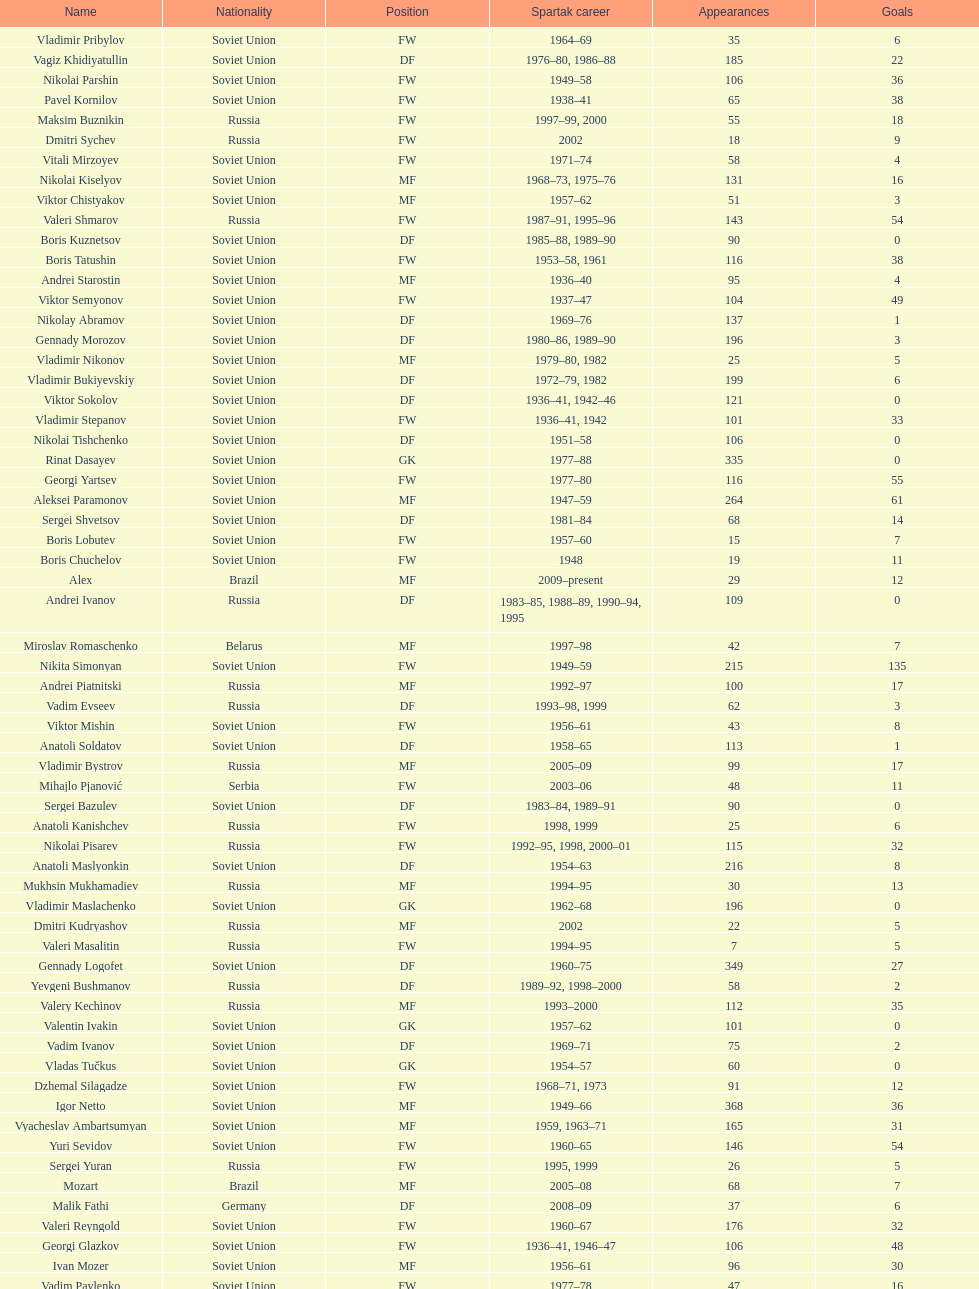How many players had at least 20 league goals scored? 56. Can you give me this table as a dict? {'header': ['Name', 'Nationality', 'Position', 'Spartak career', 'Appearances', 'Goals'], 'rows': [['Vladimir Pribylov', 'Soviet Union', 'FW', '1964–69', '35', '6'], ['Vagiz Khidiyatullin', 'Soviet Union', 'DF', '1976–80, 1986–88', '185', '22'], ['Nikolai Parshin', 'Soviet Union', 'FW', '1949–58', '106', '36'], ['Pavel Kornilov', 'Soviet Union', 'FW', '1938–41', '65', '38'], ['Maksim Buznikin', 'Russia', 'FW', '1997–99, 2000', '55', '18'], ['Dmitri Sychev', 'Russia', 'FW', '2002', '18', '9'], ['Vitali Mirzoyev', 'Soviet Union', 'FW', '1971–74', '58', '4'], ['Nikolai Kiselyov', 'Soviet Union', 'MF', '1968–73, 1975–76', '131', '16'], ['Viktor Chistyakov', 'Soviet Union', 'MF', '1957–62', '51', '3'], ['Valeri Shmarov', 'Russia', 'FW', '1987–91, 1995–96', '143', '54'], ['Boris Kuznetsov', 'Soviet Union', 'DF', '1985–88, 1989–90', '90', '0'], ['Boris Tatushin', 'Soviet Union', 'FW', '1953–58, 1961', '116', '38'], ['Andrei Starostin', 'Soviet Union', 'MF', '1936–40', '95', '4'], ['Viktor Semyonov', 'Soviet Union', 'FW', '1937–47', '104', '49'], ['Nikolay Abramov', 'Soviet Union', 'DF', '1969–76', '137', '1'], ['Gennady Morozov', 'Soviet Union', 'DF', '1980–86, 1989–90', '196', '3'], ['Vladimir Nikonov', 'Soviet Union', 'MF', '1979–80, 1982', '25', '5'], ['Vladimir Bukiyevskiy', 'Soviet Union', 'DF', '1972–79, 1982', '199', '6'], ['Viktor Sokolov', 'Soviet Union', 'DF', '1936–41, 1942–46', '121', '0'], ['Vladimir Stepanov', 'Soviet Union', 'FW', '1936–41, 1942', '101', '33'], ['Nikolai Tishchenko', 'Soviet Union', 'DF', '1951–58', '106', '0'], ['Rinat Dasayev', 'Soviet Union', 'GK', '1977–88', '335', '0'], ['Georgi Yartsev', 'Soviet Union', 'FW', '1977–80', '116', '55'], ['Aleksei Paramonov', 'Soviet Union', 'MF', '1947–59', '264', '61'], ['Sergei Shvetsov', 'Soviet Union', 'DF', '1981–84', '68', '14'], ['Boris Lobutev', 'Soviet Union', 'FW', '1957–60', '15', '7'], ['Boris Chuchelov', 'Soviet Union', 'FW', '1948', '19', '11'], ['Alex', 'Brazil', 'MF', '2009–present', '29', '12'], ['Andrei Ivanov', 'Russia', 'DF', '1983–85, 1988–89, 1990–94, 1995', '109', '0'], ['Miroslav Romaschenko', 'Belarus', 'MF', '1997–98', '42', '7'], ['Nikita Simonyan', 'Soviet Union', 'FW', '1949–59', '215', '135'], ['Andrei Piatnitski', 'Russia', 'MF', '1992–97', '100', '17'], ['Vadim Evseev', 'Russia', 'DF', '1993–98, 1999', '62', '3'], ['Viktor Mishin', 'Soviet Union', 'FW', '1956–61', '43', '8'], ['Anatoli Soldatov', 'Soviet Union', 'DF', '1958–65', '113', '1'], ['Vladimir Bystrov', 'Russia', 'MF', '2005–09', '99', '17'], ['Mihajlo Pjanović', 'Serbia', 'FW', '2003–06', '48', '11'], ['Sergei Bazulev', 'Soviet Union', 'DF', '1983–84, 1989–91', '90', '0'], ['Anatoli Kanishchev', 'Russia', 'FW', '1998, 1999', '25', '6'], ['Nikolai Pisarev', 'Russia', 'FW', '1992–95, 1998, 2000–01', '115', '32'], ['Anatoli Maslyonkin', 'Soviet Union', 'DF', '1954–63', '216', '8'], ['Mukhsin Mukhamadiev', 'Russia', 'MF', '1994–95', '30', '13'], ['Vladimir Maslachenko', 'Soviet Union', 'GK', '1962–68', '196', '0'], ['Dmitri Kudryashov', 'Russia', 'MF', '2002', '22', '5'], ['Valeri Masalitin', 'Russia', 'FW', '1994–95', '7', '5'], ['Gennady Logofet', 'Soviet Union', 'DF', '1960–75', '349', '27'], ['Yevgeni Bushmanov', 'Russia', 'DF', '1989–92, 1998–2000', '58', '2'], ['Valery Kechinov', 'Russia', 'MF', '1993–2000', '112', '35'], ['Valentin Ivakin', 'Soviet Union', 'GK', '1957–62', '101', '0'], ['Vadim Ivanov', 'Soviet Union', 'DF', '1969–71', '75', '2'], ['Vladas Tučkus', 'Soviet Union', 'GK', '1954–57', '60', '0'], ['Dzhemal Silagadze', 'Soviet Union', 'FW', '1968–71, 1973', '91', '12'], ['Igor Netto', 'Soviet Union', 'MF', '1949–66', '368', '36'], ['Vyacheslav Ambartsumyan', 'Soviet Union', 'MF', '1959, 1963–71', '165', '31'], ['Yuri Sevidov', 'Soviet Union', 'FW', '1960–65', '146', '54'], ['Sergei Yuran', 'Russia', 'FW', '1995, 1999', '26', '5'], ['Mozart', 'Brazil', 'MF', '2005–08', '68', '7'], ['Malik Fathi', 'Germany', 'DF', '2008–09', '37', '6'], ['Valeri Reyngold', 'Soviet Union', 'FW', '1960–67', '176', '32'], ['Georgi Glazkov', 'Soviet Union', 'FW', '1936–41, 1946–47', '106', '48'], ['Ivan Mozer', 'Soviet Union', 'MF', '1956–61', '96', '30'], ['Vadim Pavlenko', 'Soviet Union', 'FW', '1977–78', '47', '16'], ['Mikhail Bulgakov', 'Soviet Union', 'MF', '1970–79', '205', '39'], ['Aleksei Sokolov', 'Soviet Union', 'FW', '1938–41, 1942, 1944–47', '114', '49'], ['Yuri Kovtun', 'Russia', 'DF', '1999–2005', '122', '7'], ['Vladimir Petrov', 'Soviet Union', 'DF', '1959–71', '174', '5'], ['Anatoli Ilyin', 'Soviet Union', 'FW', '1949–62', '228', '84'], ['Anatoli Seglin', 'Soviet Union', 'DF', '1945–52', '83', '0'], ['Valeri Dikaryov', 'Soviet Union', 'DF', '1961–67', '192', '1'], ['Andrei Rudakov', 'Soviet Union', 'FW', '1985–87', '49', '17'], ['Aleksandr Kokorev', 'Soviet Union', 'MF', '1972–80', '90', '4'], ['Artyom Bezrodny', 'Russia', 'MF', '1995–97, 1998–2003', '55', '10'], ['Andrejs Štolcers', 'Latvia', 'MF', '2000', '11', '5'], ['Sergey Rodionov', 'Russia', 'FW', '1979–90, 1993–95', '303', '124'], ['Andrei Protasov', 'Soviet Union', 'FW', '1939–41', '32', '10'], ['Konstantin Malinin', 'Soviet Union', 'DF', '1939–50', '140', '7'], ['Aleksandr Bubnov', 'Soviet Union', 'DF', '1983–89', '169', '3'], ['Sergei Rozhkov', 'Soviet Union', 'MF', '1961–65, 1967–69, 1974', '143', '8'], ['Valeri Gladilin', 'Soviet Union', 'MF', '1974–78, 1983–84', '169', '28'], ['Dmitri Popov', 'Russia', 'DF', '1989–93', '78', '7'], ['Evgeny Lovchev', 'Soviet Union', 'MF', '1969–78', '249', '30'], ['Viktor Konovalov', 'Soviet Union', 'MF', '1960–61', '24', '5'], ['Viktor Samokhin', 'Soviet Union', 'MF', '1974–81', '188', '3'], ['Dmitri Radchenko', 'Russia', 'FW', '1991–93', '61', '27'], ['Grigori Tuchkov', 'Soviet Union', 'DF', '1937–41, 1942, 1944', '74', '2'], ['Yegor Titov', 'Russia', 'MF', '1992–2008', '324', '86'], ['Aleksandr Pavlenko', 'Russia', 'MF', '2001–07, 2008–09', '110', '11'], ['Sergei Artemyev', 'Soviet Union', 'MF', '1936–40', '53', '0'], ['Yuri Sedov', 'Soviet Union', 'DF', '1948–55, 1957–59', '176', '2'], ['Viktor Papayev', 'Soviet Union', 'MF', '1968–73, 1975–76', '174', '10'], ['Aleksandr Mostovoi', 'Soviet Union', 'MF', '1986–91', '106', '34'], ['Oleg Romantsev', 'Soviet Union', 'DF', '1976–83', '180', '6'], ['Igor Shalimov', 'Russia', 'MF', '1986–91', '95', '20'], ['Aleksandr Grebnev', 'Soviet Union', 'DF', '1966–69', '54', '1'], ['Sergey Shavlo', 'Soviet Union', 'MF', '1977–82, 1984–85', '256', '48'], ['Vladimir Redin', 'Soviet Union', 'MF', '1970–74, 1976', '90', '12'], ['Aleksandr Prokhorov', 'Soviet Union', 'GK', '1972–75, 1976–78', '143', '0'], ['Yevgeni Kuznetsov', 'Soviet Union', 'MF', '1982–89', '209', '23'], ['Anatoli Isayev', 'Soviet Union', 'FW', '1953–62', '159', '53'], ['Vladimir Kapustin', 'Soviet Union', 'MF', '1985–89', '51', '1'], ['Roman Pavlyuchenko', 'Russia', 'FW', '2003–08', '141', '69'], ['Yuri Syomin', 'Soviet Union', 'MF', '1965–67', '43', '6'], ['Nikolay Dementyev', 'Soviet Union', 'FW', '1946–54', '186', '55'], ['Vasili Kulkov', 'Russia', 'DF', '1986, 1989–91, 1995, 1997', '93', '4'], ['Vladimir Yankin', 'Soviet Union', 'MF', '1966–70', '93', '19'], ['Anatoli Akimov', 'Soviet Union', 'GK', '1936–37, 1939–41', '60', '0'], ['Stanislav Cherchesov', 'Russia', 'GK', '1984–87, 1989–93, 1995, 2002', '149', '0'], ['Aleksandr Sorokin', 'Soviet Union', 'MF', '1977–80', '107', '9'], ['Ivan Konov', 'Soviet Union', 'FW', '1945–48', '85', '31'], ['Sergei Novikov', 'Soviet Union', 'MF', '1978–80, 1985–89', '70', '12'], ['Alexander Mirzoyan', 'Soviet Union', 'DF', '1979–83', '80', '9'], ['Sergei Gorlukovich', 'Russia', 'DF', '1996–98', '83', '5'], ['Valery Karpin', 'Russia', 'MF', '1990–94', '117', '28'], ['Martin Jiránek', 'Czech Republic', 'DF', '2004–present', '126', '3'], ['Valentin Yemyshev', 'Soviet Union', 'FW', '1948–53', '23', '9'], ['Mikhail Rusyayev', 'Russia', 'FW', '1981–87, 1992', '47', '9'], ['Igor Mitreski', 'Macedonia', 'DF', '2001–04', '85', '0'], ['Radoslav Kováč', 'Czech Republic', 'MF', '2005–08', '101', '9'], ['Hennadiy Perepadenko', 'Ukraine', 'MF', '1990–91, 1992', '51', '6'], ['Nikolai Osyanin', 'Soviet Union', 'DF', '1966–71, 1974–76', '248', '50'], ['Aleksandr Samedov', 'Russia', 'MF', '2001–05', '47', '6'], ['Ivan Varlamov', 'Soviet Union', 'DF', '1964–68', '75', '0'], ['Luis Robson', 'Brazil', 'FW', '1997–2001', '102', '32'], ['Viktor Bulatov', 'Russia', 'MF', '1999–2001', '87', '7'], ['Sergei Salnikov', 'Soviet Union', 'FW', '1946–49, 1955–60', '201', '64'], ['Igor Lediakhov', 'Russia', 'MF', '1992–94', '65', '21'], ['Galimzyan Khusainov', 'Soviet Union', 'FW', '1961–73', '346', '102'], ['Yuri Falin', 'Soviet Union', 'MF', '1961–65, 1967', '133', '34'], ['Oleg Timakov', 'Soviet Union', 'MF', '1945–54', '182', '19'], ['Boris Smyslov', 'Soviet Union', 'FW', '1945–48', '45', '6'], ['Ilya Tsymbalar', 'Russia', 'MF', '1993–99', '146', '42'], ['Yuri Gavrilov', 'Soviet Union', 'MF', '1977–85', '280', '89'], ['Fyodor Cherenkov', 'Russia', 'MF', '1977–90, 1991, 1993', '398', '95'], ['Vladimir Beschastnykh', 'Russia', 'FW', '1991–94, 2001–02', '104', '56'], ['Aleksandr Piskaryov', 'Soviet Union', 'FW', '1971–75', '117', '33'], ['Clemente Rodríguez', 'Argentina', 'DF', '2004–06, 2008–09', '71', '3'], ['Aleksei Melyoshin', 'Russia', 'MF', '1995–2000', '68', '5'], ['Anzor Kavazashvili', 'Soviet Union', 'GK', '1969–71', '74', '0'], ['Vasili Sokolov', 'Soviet Union', 'DF', '1938–41, 1942–51', '262', '2'], ['Serghei Covalciuc', 'Moldova', 'MF', '2004–09', '90', '2'], ['Edgar Gess', 'Soviet Union', 'MF', '1979–83', '114', '26'], ['Dmitri Khlestov', 'Russia', 'DF', '1989–2000, 2002', '201', '6'], ['Yevgeni Sidorov', 'Soviet Union', 'MF', '1974–81, 1984–85', '191', '18'], ['Yuri Susloparov', 'Soviet Union', 'DF', '1986–90', '80', '1'], ['Ramiz Mamedov', 'Russia', 'DF', '1991–98', '125', '6'], ['Denis Boyarintsev', 'Russia', 'MF', '2005–07, 2009', '91', '9'], ['Dimitri Ananko', 'Russia', 'DF', '1990–94, 1995–2002', '150', '1'], ['Viktor Terentyev', 'Soviet Union', 'FW', '1948–53', '103', '34'], ['Valeri Zenkov', 'Soviet Union', 'DF', '1971–74', '59', '1'], ['Maksym Kalynychenko', 'Ukraine', 'MF', '2000–08', '134', '22'], ['Aleksandr Kalashnikov', 'Soviet Union', 'FW', '1978–82', '67', '16'], ['Viktor Onopko', 'Russia', 'DF', '1992–95', '108', '23'], ['Vasili Kalinov', 'Soviet Union', 'MF', '1969–72', '83', '10'], ['Serafim Kholodkov', 'Soviet Union', 'DF', '1941, 1946–49', '90', '0'], ['Viktor Pasulko', 'Soviet Union', 'MF', '1987–89', '75', '16'], ['Boris Pozdnyakov', 'Soviet Union', 'DF', '1978–84, 1989–91', '145', '3'], ['Dmitri Alenichev', 'Russia', 'MF', '1994–98, 2004–06', '143', '21'], ['Aleksandr Filimonov', 'Russia', 'GK', '1996–2001', '147', '0'], ['Mikhail Ogonkov', 'Soviet Union', 'DF', '1953–58, 1961', '78', '0'], ['Boris Petrov', 'Soviet Union', 'FW', '1962', '18', '5'], ['Roman Shishkin', 'Russia', 'DF', '2003–08', '54', '1'], ['Alexey Korneyev', 'Soviet Union', 'DF', '1957–67', '177', '0'], ['Yuriy Nikiforov', 'Russia', 'DF', '1993–96', '85', '16'], ['Wojciech Kowalewski', 'Poland', 'GK', '2003–07', '94', '0'], ['Vladimir Sochnov', 'Soviet Union', 'DF', '1981–85, 1989', '148', '9'], ['Aleksei Leontyev', 'Soviet Union', 'GK', '1940–49', '109', '0'], ['Sergei Olshansky', 'Soviet Union', 'DF', '1969–75', '138', '7'], ['Florin Şoavă', 'Romania', 'DF', '2004–05, 2007–08', '52', '1'], ['Fernando Cavenaghi', 'Argentina', 'FW', '2004–06', '51', '12'], ['Eduard Tsykhmeystruk', 'Ukraine', 'FW', '2001–02', '35', '5'], ['Vasili Baranov', 'Belarus', 'MF', '1998–2003', '120', '18'], ['Aleksei Yeryomenko', 'Soviet Union', 'MF', '1986–87', '26', '5'], ['Welliton', 'Brazil', 'FW', '2007–present', '77', '51'], ['Dmytro Parfenov', 'Ukraine', 'DF', '1998–2005', '125', '15'], ['Konstantin Ryazantsev', 'Soviet Union', 'MF', '1941, 1944–51', '114', '5'], ['Vladimir Chernyshev', 'Soviet Union', 'GK', '1946–55', '74', '0'], ['Stipe Pletikosa', 'Croatia', 'GK', '2007–present', '63', '0'], ['Aleksandr Rystsov', 'Soviet Union', 'FW', '1947–54', '100', '16'], ['Valeri Andreyev', 'Soviet Union', 'FW', '1970–76, 1977', '97', '21'], ['Nikolai Gulyayev', 'Soviet Union', 'MF', '1937–46', '76', '7'], ['Aleksandr Shirko', 'Russia', 'FW', '1993–2001', '128', '40'], ['Aleksandr Minayev', 'Soviet Union', 'MF', '1972–75', '92', '10'], ['Andrey Tikhonov', 'Russia', 'MF', '1992–2000', '191', '68'], ['Viktor Yevlentyev', 'Soviet Union', 'MF', '1963–65, 1967–70', '56', '11'], ['Martin Stranzl', 'Austria', 'DF', '2006–present', '80', '3'], ['Vladimir Yanishevskiy', 'Soviet Union', 'FW', '1965–66', '46', '7'], ['Leonid Rumyantsev', 'Soviet Union', 'FW', '1936–40', '26', '8'], ['Anatoly Krutikov', 'Soviet Union', 'DF', '1959–69', '269', '9'], ['Nikita Bazhenov', 'Russia', 'FW', '2004–present', '92', '17']]} 